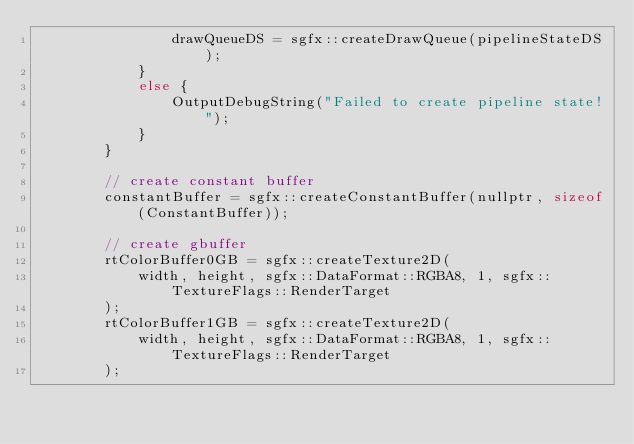Convert code to text. <code><loc_0><loc_0><loc_500><loc_500><_C++_>                drawQueueDS = sgfx::createDrawQueue(pipelineStateDS);
            }
            else {
                OutputDebugString("Failed to create pipeline state!");
            }
        }

        // create constant buffer
        constantBuffer = sgfx::createConstantBuffer(nullptr, sizeof(ConstantBuffer));

        // create gbuffer
        rtColorBuffer0GB = sgfx::createTexture2D(
            width, height, sgfx::DataFormat::RGBA8, 1, sgfx::TextureFlags::RenderTarget
        );
        rtColorBuffer1GB = sgfx::createTexture2D(
            width, height, sgfx::DataFormat::RGBA8, 1, sgfx::TextureFlags::RenderTarget
        );</code> 